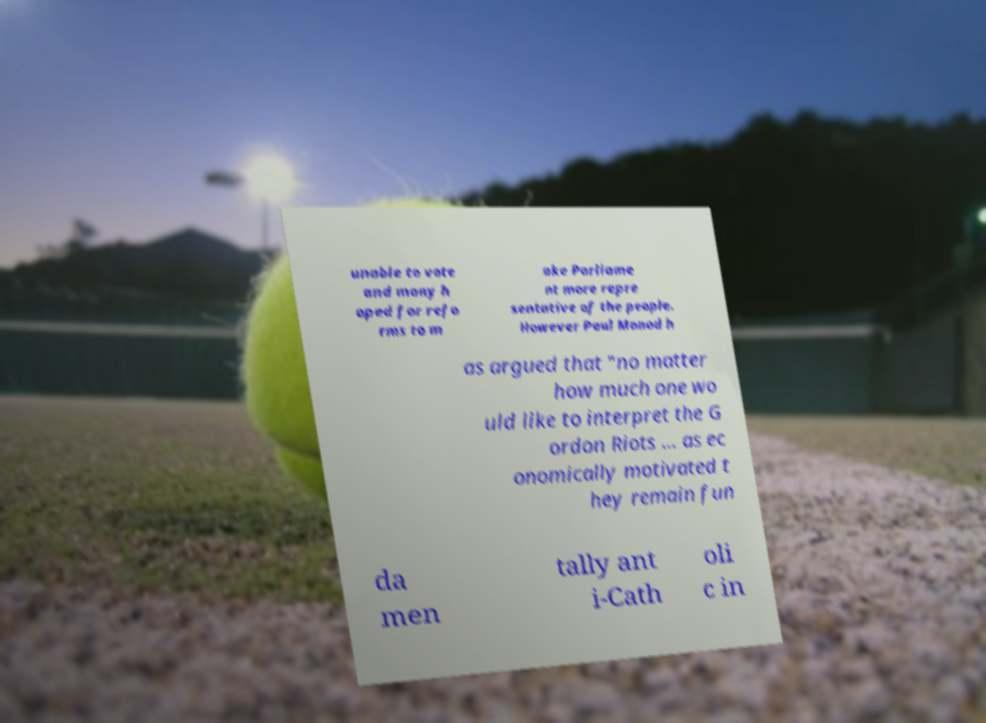I need the written content from this picture converted into text. Can you do that? unable to vote and many h oped for refo rms to m ake Parliame nt more repre sentative of the people. However Paul Monod h as argued that "no matter how much one wo uld like to interpret the G ordon Riots ... as ec onomically motivated t hey remain fun da men tally ant i-Cath oli c in 